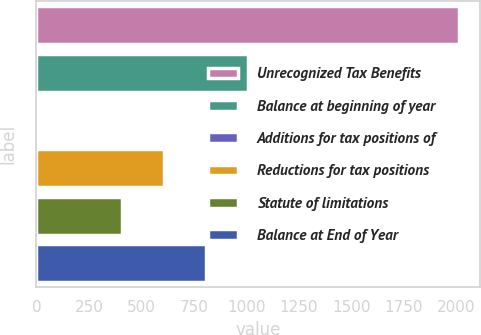<chart> <loc_0><loc_0><loc_500><loc_500><bar_chart><fcel>Unrecognized Tax Benefits<fcel>Balance at beginning of year<fcel>Additions for tax positions of<fcel>Reductions for tax positions<fcel>Statute of limitations<fcel>Balance at End of Year<nl><fcel>2014<fcel>1009.45<fcel>4.9<fcel>607.63<fcel>406.72<fcel>808.54<nl></chart> 